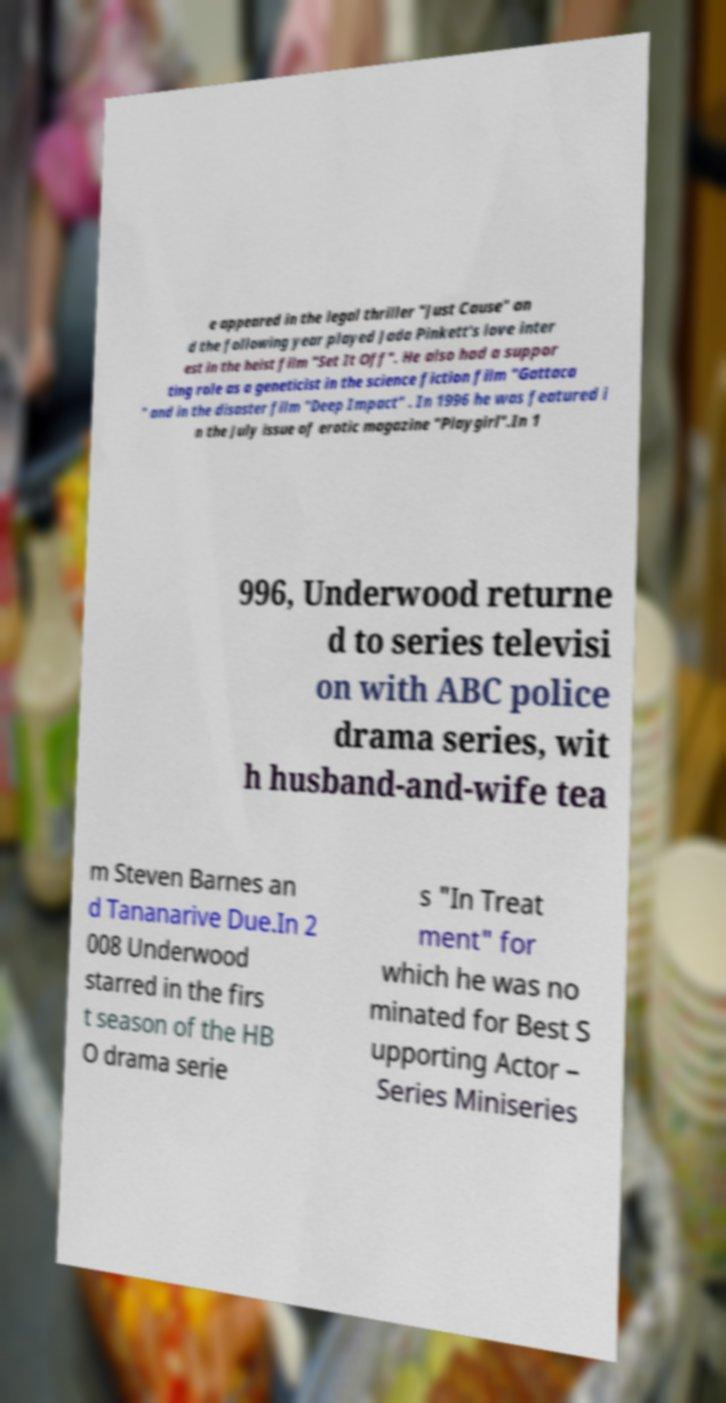Please identify and transcribe the text found in this image. e appeared in the legal thriller "Just Cause" an d the following year played Jada Pinkett's love inter est in the heist film "Set It Off". He also had a suppor ting role as a geneticist in the science fiction film "Gattaca " and in the disaster film "Deep Impact" . In 1996 he was featured i n the July issue of erotic magazine "Playgirl".In 1 996, Underwood returne d to series televisi on with ABC police drama series, wit h husband-and-wife tea m Steven Barnes an d Tananarive Due.In 2 008 Underwood starred in the firs t season of the HB O drama serie s "In Treat ment" for which he was no minated for Best S upporting Actor – Series Miniseries 